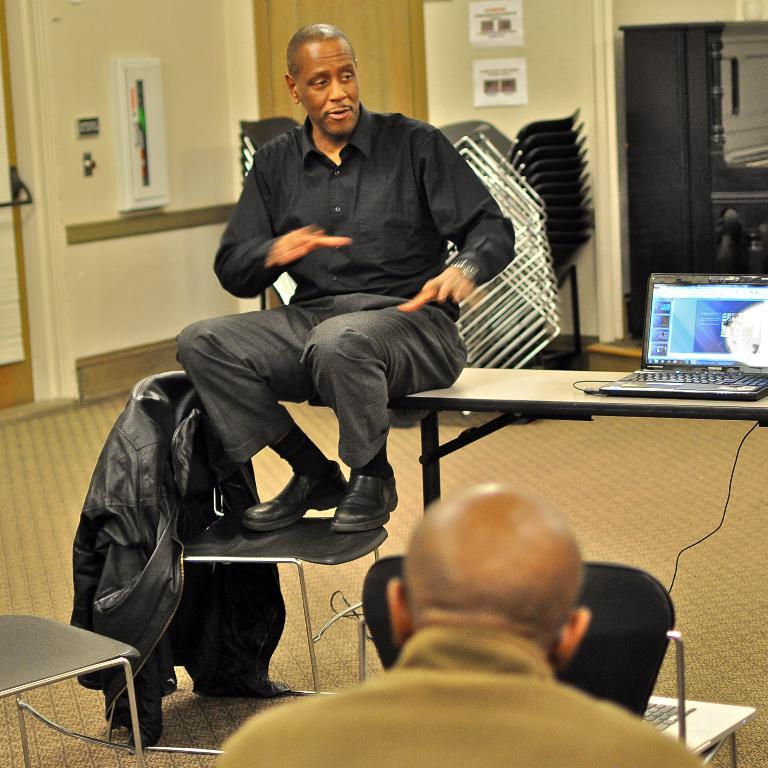What can be seen in the background of the image? There is a wall in the image. How many people are present in the image? There are two persons in the image. What is one person doing in the image? One person is sitting on a table. What type of furniture is present in the image? There is a chair in the image. What type of clothing is visible in the image? There is a jacket in the image. What electronic device is on the table in the image? There is a laptop on the table. What type of produce is being harvested by the sister in the image? There is no sister or produce present in the image. How does the laptop burn in the image? The laptop does not burn in the image; it is not on fire or experiencing any damage. 